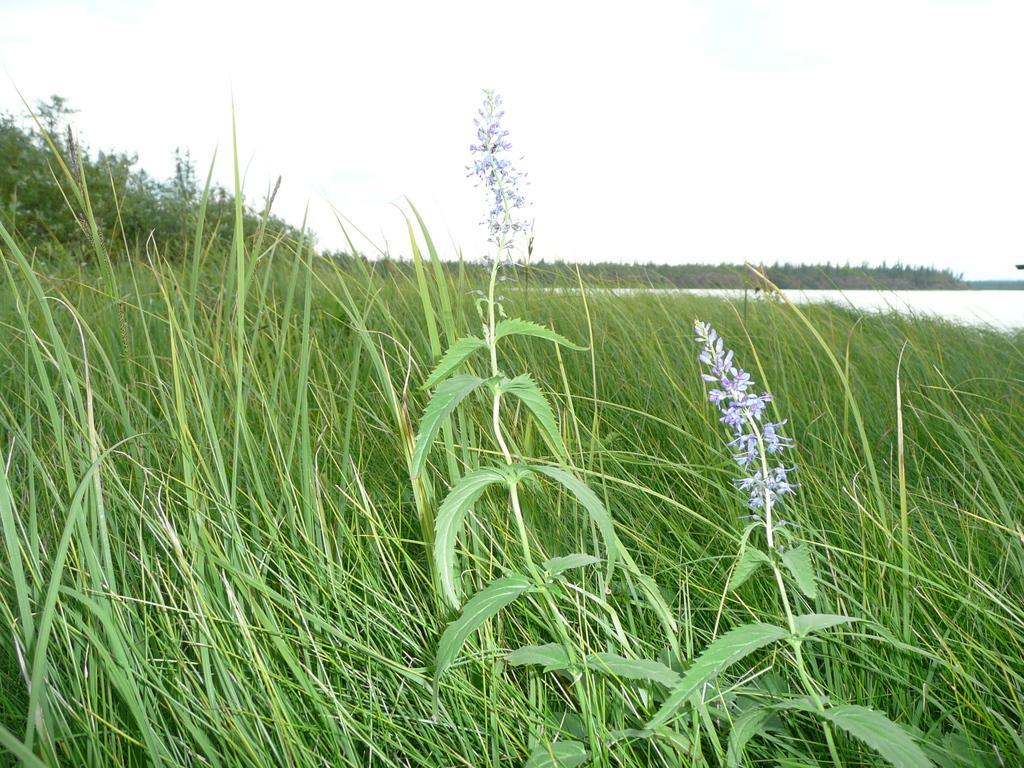Can you describe this image briefly? In this picture we can see few flowers to the plant, behind we can see grass and we can see water. 